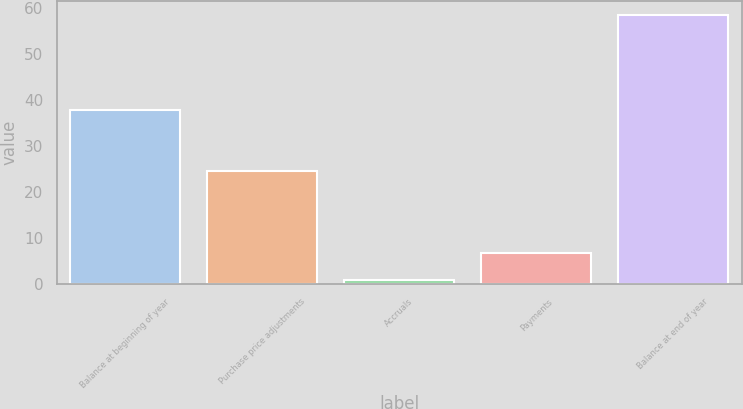<chart> <loc_0><loc_0><loc_500><loc_500><bar_chart><fcel>Balance at beginning of year<fcel>Purchase price adjustments<fcel>Accruals<fcel>Payments<fcel>Balance at end of year<nl><fcel>37.8<fcel>24.6<fcel>0.9<fcel>6.66<fcel>58.5<nl></chart> 